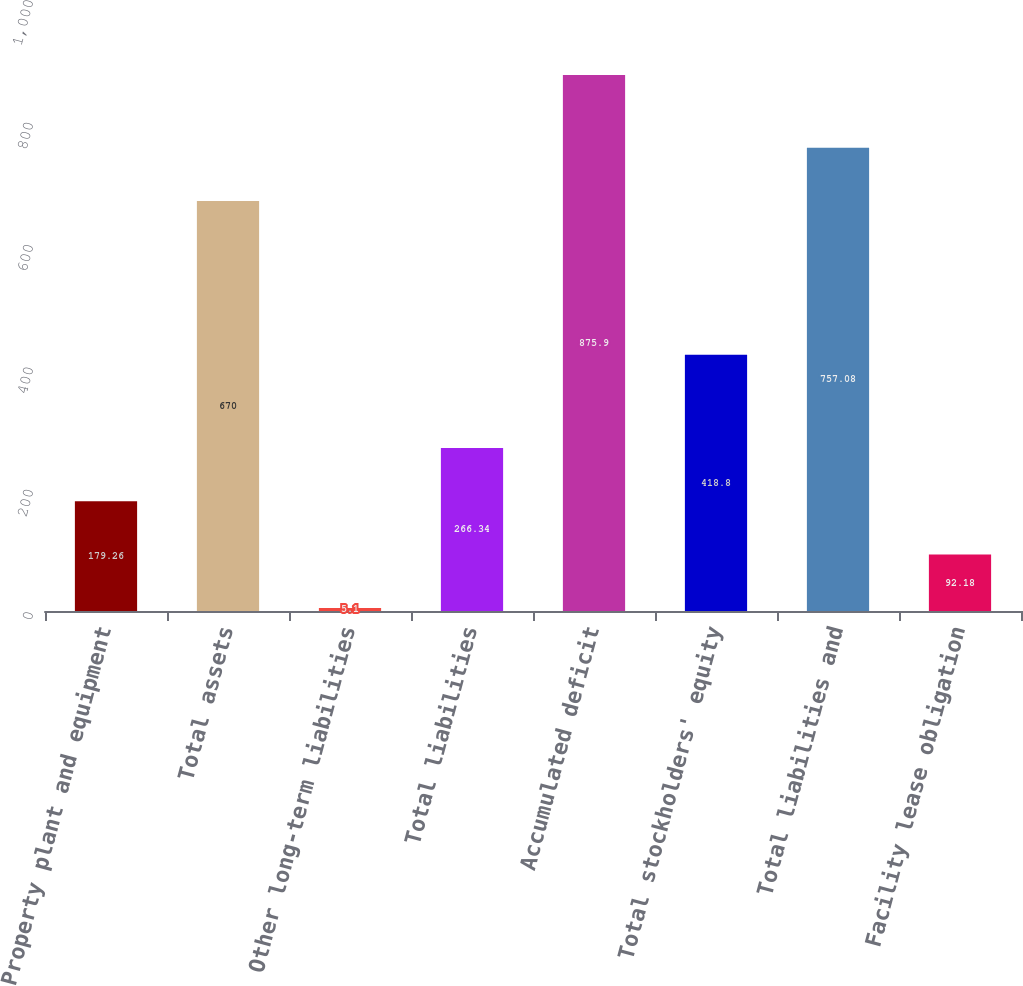<chart> <loc_0><loc_0><loc_500><loc_500><bar_chart><fcel>Property plant and equipment<fcel>Total assets<fcel>Other long-term liabilities<fcel>Total liabilities<fcel>Accumulated deficit<fcel>Total stockholders' equity<fcel>Total liabilities and<fcel>Facility lease obligation<nl><fcel>179.26<fcel>670<fcel>5.1<fcel>266.34<fcel>875.9<fcel>418.8<fcel>757.08<fcel>92.18<nl></chart> 